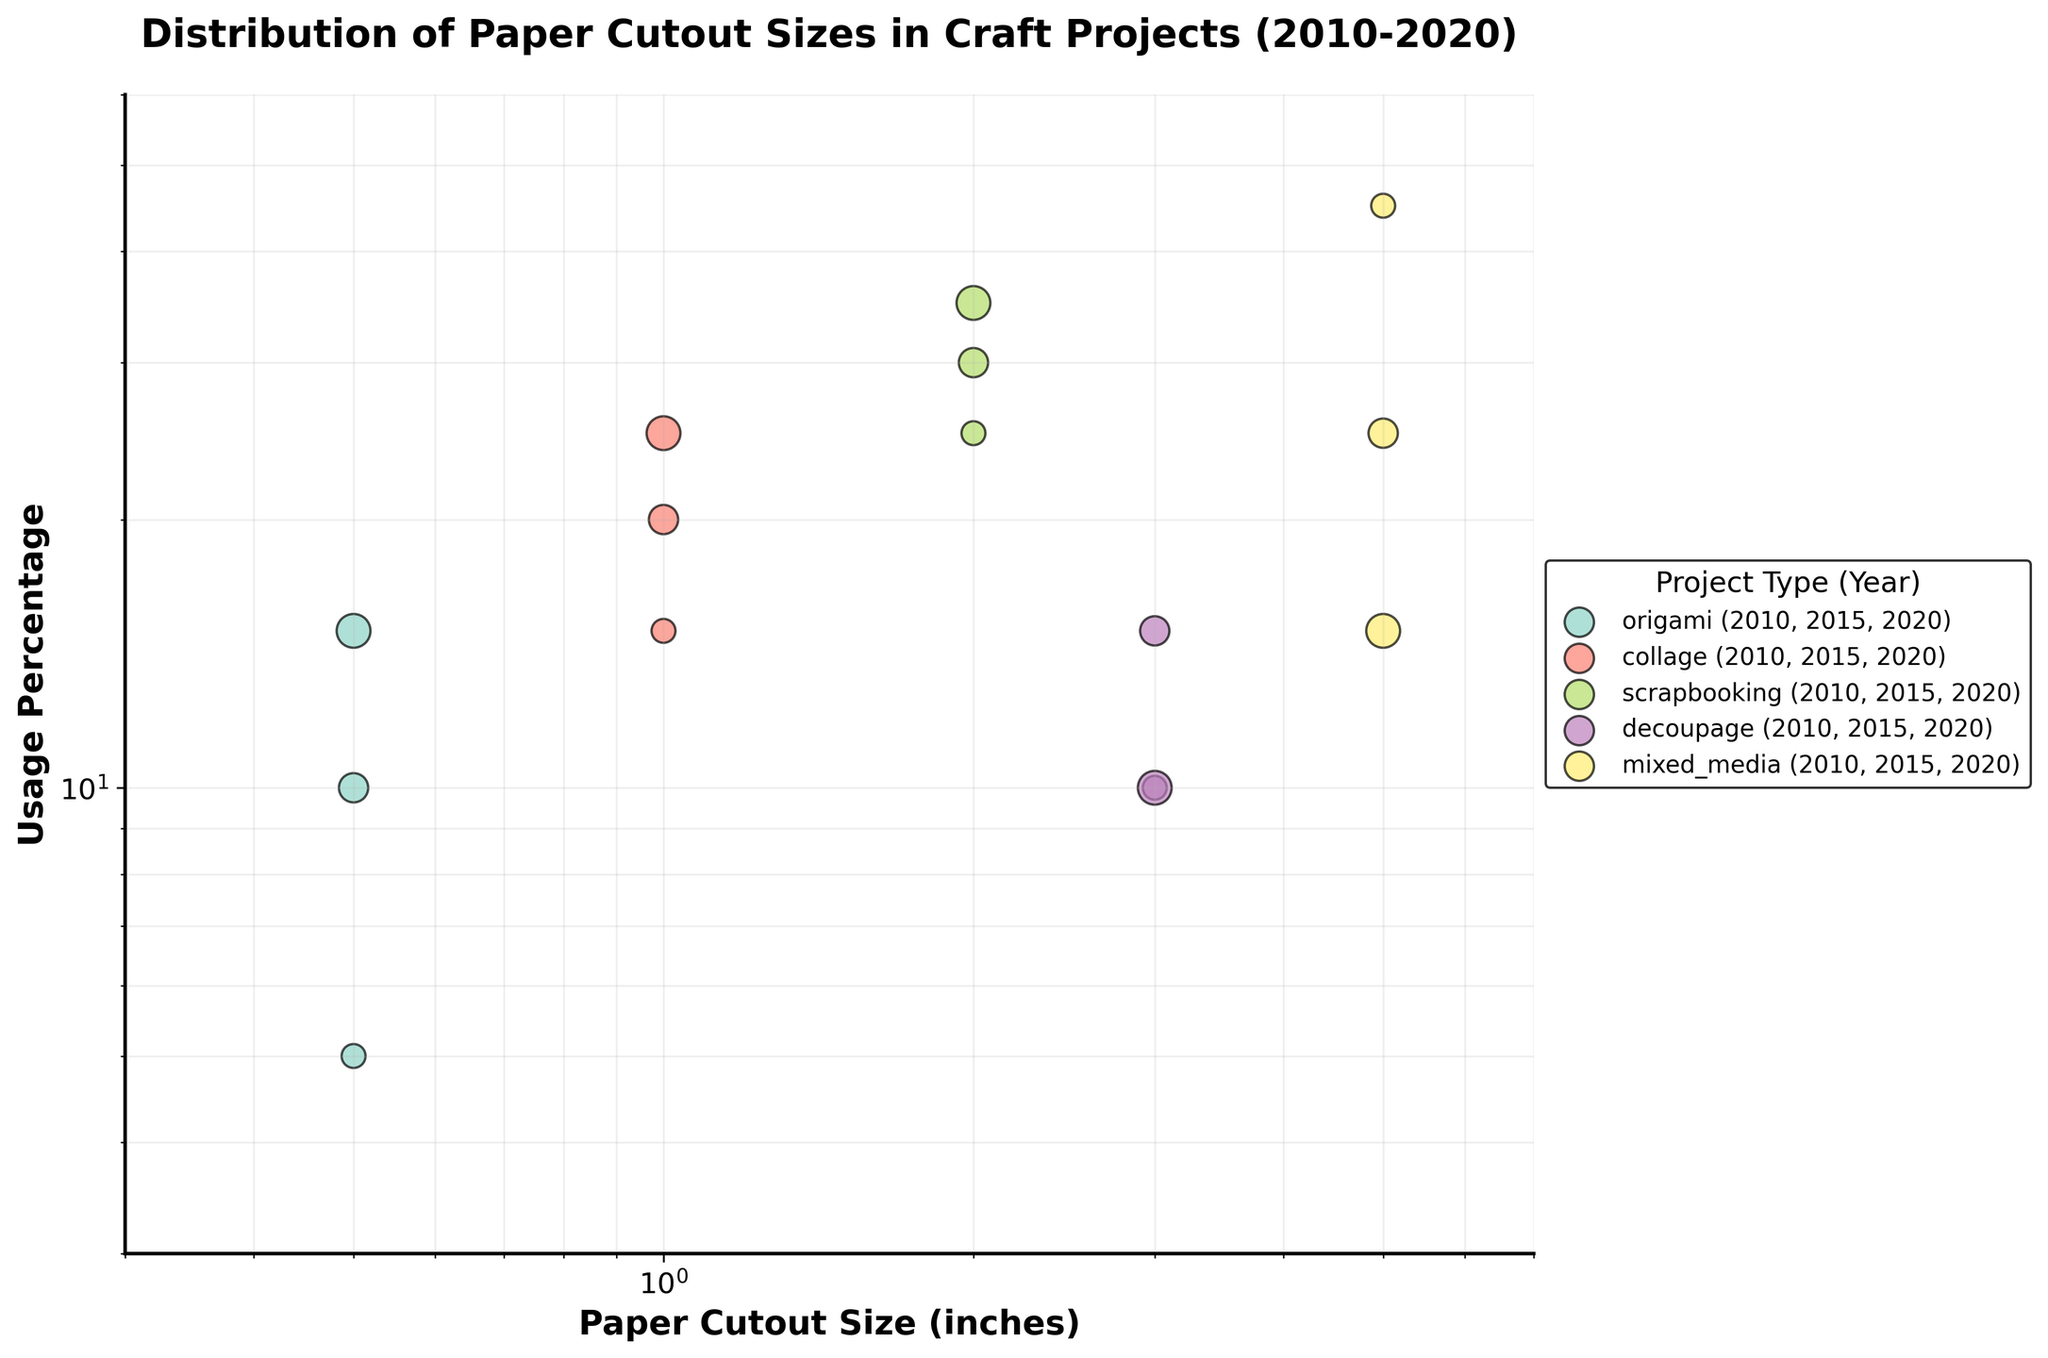What is the title of the figure? The title of a figure is usually at the top and provides a brief description of what the figure is about. In this case, it reads "Distribution of Paper Cutout Sizes in Craft Projects (2010-2020)".
Answer: Distribution of Paper Cutout Sizes in Craft Projects (2010-2020) What do the axes represent? The x-axis represents "Paper Cutout Size (inches)", and the y-axis represents "Usage Percentage". These labels are usually placed alongside the respective axes.
Answer: Paper Cutout Size (inches); Usage Percentage Which project type has the largest usage percentage in 2010? The scatter points are color-coded by project types, and the legend indicates which color corresponds to each project type. The largest usage percentage in 2010 is a point at 45% for mixed_media.
Answer: mixed_media What is the trend in origami usage from 2010 to 2020? The scatter points for origami (indicated by its label in the legend) show an increasing trend in usage percentage from 5% in 2010 to 15% in 2020.
Answer: Increasing How many project types are represented in the figure? The legend lists the different project types along with their years. By counting them, we see there are five project types: origami, collage, scrapbooking, decoupage, and mixed_media.
Answer: Five Which paper cutout size is the most used for scrapbooking in 2020? For scrapbooking, identifying the point in 2020 (by its color in the legend) shows that size 2.0 inches has the highest usage percentage in 2020.
Answer: 2.0 inches How does the usage percentage of mixed_media change over time? By looking at the scatter points for mixed_media in the years 2010 (45%), 2015 (25%), and 2020 (15%), we see a decreasing trend.
Answer: Decreasing What size cutout is most common for decoupage projects in 2015? By checking the data points for decoupage and the year 2015 in the figure, we notice that they use 3.0-inch cutouts with 15% usage.
Answer: 3.0 inches Which project type had the biggest increase in usage percentage from 2010 to 2020? Comparing the usage percentages for each project type in 2010 and 2020, origami increased from 5% to 15%, which is a 10% rise, while other projects had smaller changes.
Answer: Origami What does the log scale in the figure represent? On a log scale, equal distances represent multiplicative changes. This is useful for comparing relative changes and ranges in data, as shown in this craft project figure for both the x and y axes.
Answer: Relative changes and ranges 